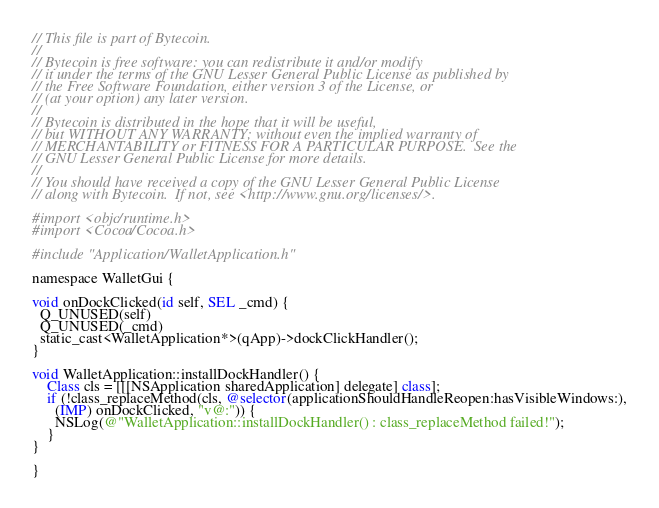<code> <loc_0><loc_0><loc_500><loc_500><_ObjectiveC_>// This file is part of Bytecoin.
//
// Bytecoin is free software: you can redistribute it and/or modify
// it under the terms of the GNU Lesser General Public License as published by
// the Free Software Foundation, either version 3 of the License, or
// (at your option) any later version.
//
// Bytecoin is distributed in the hope that it will be useful,
// but WITHOUT ANY WARRANTY; without even the implied warranty of
// MERCHANTABILITY or FITNESS FOR A PARTICULAR PURPOSE.  See the
// GNU Lesser General Public License for more details.
//
// You should have received a copy of the GNU Lesser General Public License
// along with Bytecoin.  If not, see <http://www.gnu.org/licenses/>.

#import <objc/runtime.h>
#import <Cocoa/Cocoa.h>

#include "Application/WalletApplication.h"

namespace WalletGui {

void onDockClicked(id self, SEL _cmd) {
  Q_UNUSED(self)
  Q_UNUSED(_cmd)
  static_cast<WalletApplication*>(qApp)->dockClickHandler();
}

void WalletApplication::installDockHandler() {
    Class cls = [[[NSApplication sharedApplication] delegate] class];
    if (!class_replaceMethod(cls, @selector(applicationShouldHandleReopen:hasVisibleWindows:),
      (IMP) onDockClicked, "v@:")) {
      NSLog(@"WalletApplication::installDockHandler() : class_replaceMethod failed!");
    }
}

}
</code> 